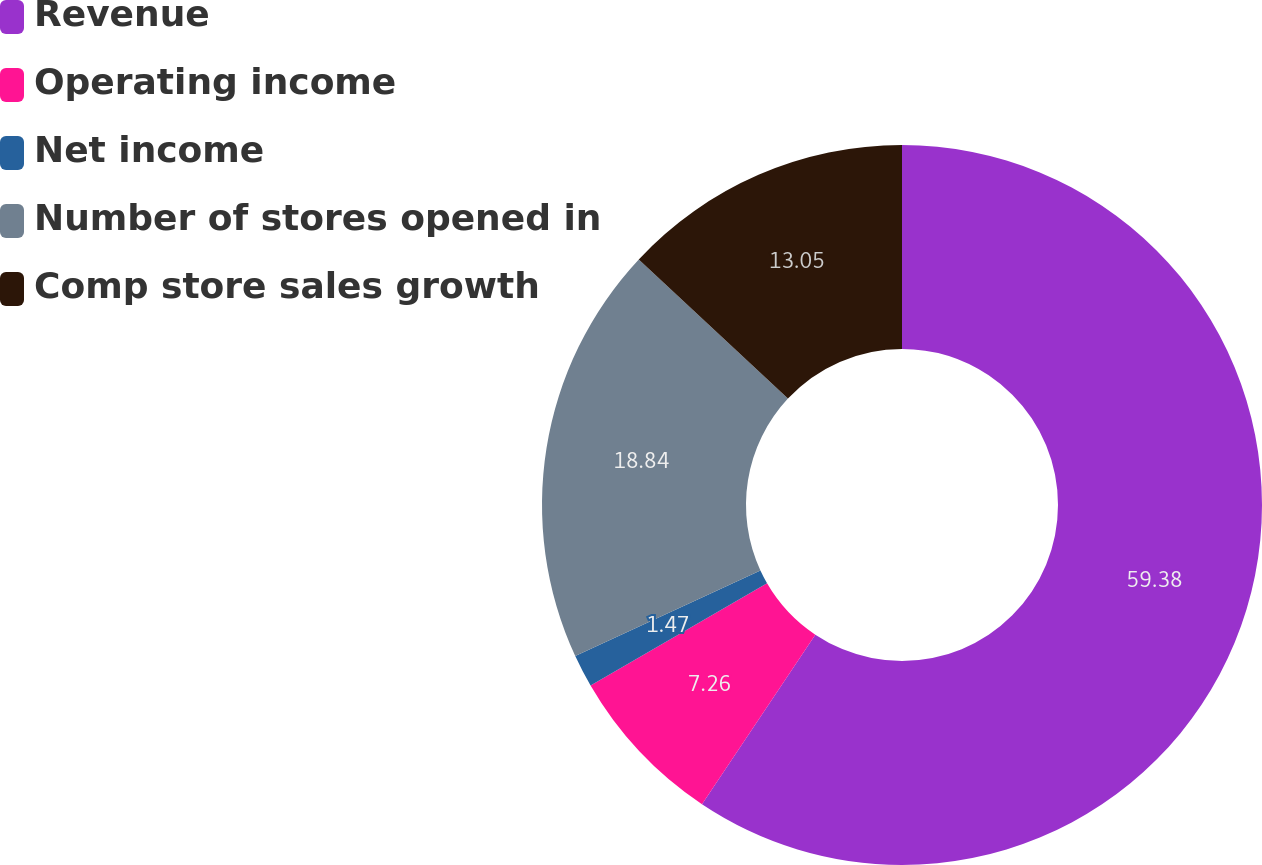<chart> <loc_0><loc_0><loc_500><loc_500><pie_chart><fcel>Revenue<fcel>Operating income<fcel>Net income<fcel>Number of stores opened in<fcel>Comp store sales growth<nl><fcel>59.37%<fcel>7.26%<fcel>1.47%<fcel>18.84%<fcel>13.05%<nl></chart> 